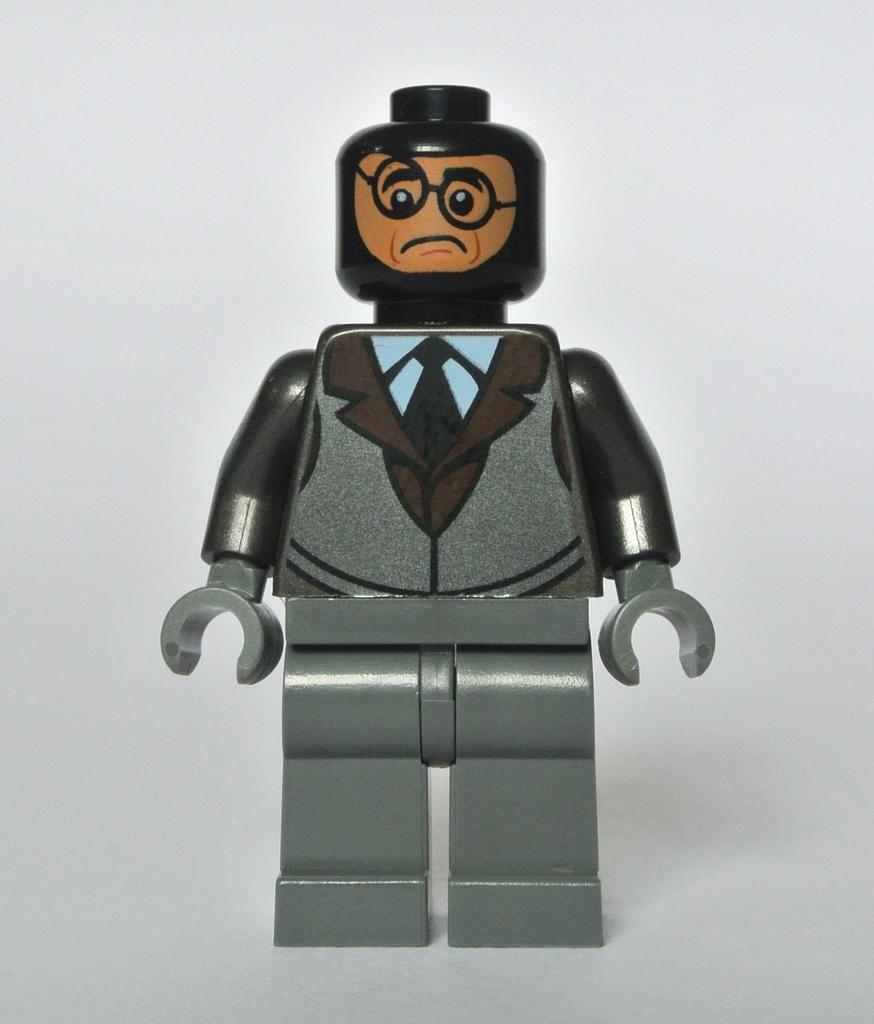Can you describe this image briefly? It's a toy which is in the shape of a man. 